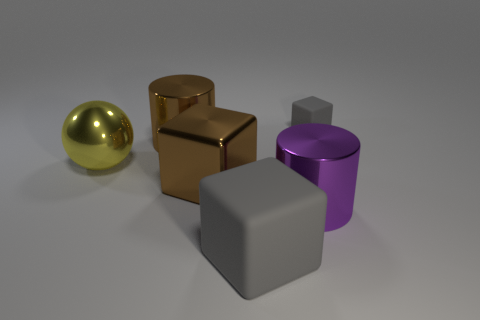Are there fewer big matte things behind the large yellow shiny ball than big balls?
Offer a terse response. Yes. Is there a big brown cube made of the same material as the yellow sphere?
Provide a succinct answer. Yes. Is the size of the yellow thing the same as the rubber object behind the brown metallic block?
Offer a very short reply. No. Is there a tiny block of the same color as the large metallic sphere?
Give a very brief answer. No. Is the tiny gray cube made of the same material as the big brown block?
Your answer should be compact. No. There is a small gray matte block; what number of big blocks are to the left of it?
Keep it short and to the point. 2. What material is the cube that is behind the large matte thing and in front of the large brown shiny cylinder?
Your answer should be compact. Metal. How many red balls are the same size as the yellow shiny sphere?
Your response must be concise. 0. What color is the rubber block to the left of the gray matte block to the right of the purple shiny cylinder?
Offer a very short reply. Gray. Are any small objects visible?
Your answer should be very brief. Yes. 